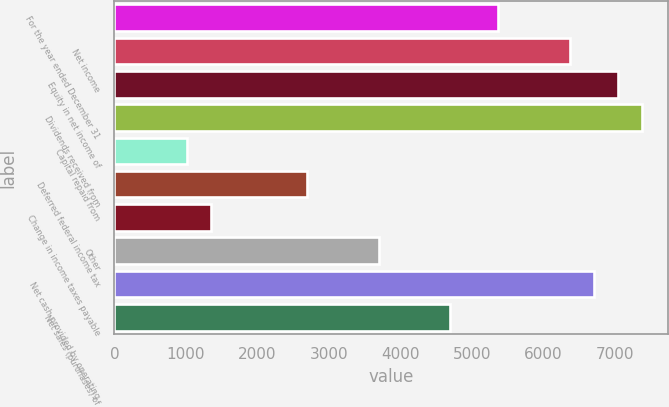Convert chart to OTSL. <chart><loc_0><loc_0><loc_500><loc_500><bar_chart><fcel>For the year ended December 31<fcel>Net income<fcel>Equity in net income of<fcel>Dividends received from<fcel>Capital repaid from<fcel>Deferred federal income tax<fcel>Change in income taxes payable<fcel>Other<fcel>Net cash provided by operating<fcel>Net sales (purchases) of<nl><fcel>5369.2<fcel>6373.3<fcel>7042.7<fcel>7377.4<fcel>1018.1<fcel>2691.6<fcel>1352.8<fcel>3695.7<fcel>6708<fcel>4699.8<nl></chart> 